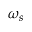<formula> <loc_0><loc_0><loc_500><loc_500>\omega _ { s }</formula> 